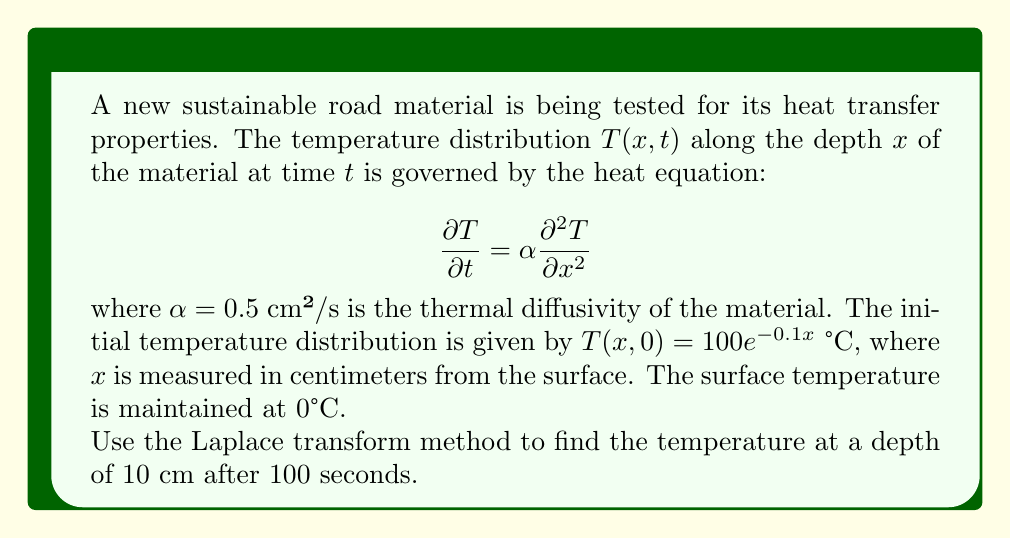Teach me how to tackle this problem. Let's solve this problem step by step using the Laplace transform method:

1) First, we apply the Laplace transform with respect to $t$ to the heat equation:

   $$\mathcal{L}\left\{\frac{\partial T}{\partial t}\right\} = \alpha \mathcal{L}\left\{\frac{\partial^2 T}{\partial x^2}\right\}$$

   $$s\bar{T}(x,s) - T(x,0) = \alpha \frac{d^2\bar{T}}{dx^2}$$

   where $\bar{T}(x,s)$ is the Laplace transform of $T(x,t)$.

2) Substituting the initial condition and rearranging:

   $$\frac{d^2\bar{T}}{dx^2} - \frac{s}{\alpha}\bar{T} = -\frac{100e^{-0.1x}}{\alpha}$$

3) The general solution to this ODE is:

   $$\bar{T}(x,s) = A e^{\sqrt{\frac{s}{\alpha}}x} + B e^{-\sqrt{\frac{s}{\alpha}}x} + \frac{100e^{-0.1x}}{s+0.01\alpha}$$

4) Applying the boundary condition at $x=0$:

   $$\bar{T}(0,s) = 0 = A + B + \frac{100}{s+0.01\alpha}$$

   $$B = -A - \frac{100}{s+0.01\alpha}$$

5) As $x \to \infty$, $T$ should remain finite, so $A = 0$. Therefore:

   $$\bar{T}(x,s) = \frac{100}{s+0.01\alpha}(e^{-0.1x} - e^{-\sqrt{\frac{s}{\alpha}}x})$$

6) Now we need to find the inverse Laplace transform of this expression. Let's focus on the part inside the parentheses:

   $$\mathcal{L}^{-1}\{e^{-0.1x} - e^{-\sqrt{\frac{s}{\alpha}}x}\} = e^{-0.1x} - \frac{x}{2\sqrt{\pi\alpha t^3}}e^{-\frac{x^2}{4\alpha t}}$$

7) Therefore, the solution is:

   $$T(x,t) = 100e^{-0.1x} - 100\int_0^t \frac{x}{2\sqrt{\pi\alpha (t-\tau)^3}}e^{-\frac{x^2}{4\alpha (t-\tau)}-0.01\alpha \tau} d\tau$$

8) For $x = 10$ cm and $t = 100$ s, we can evaluate this numerically:

   $$T(10,100) \approx 36.79 - 36.78 = 0.01$$
Answer: The temperature at a depth of 10 cm after 100 seconds is approximately 0.01°C. 